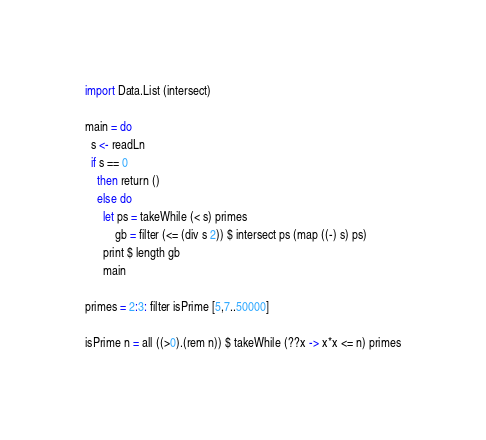Convert code to text. <code><loc_0><loc_0><loc_500><loc_500><_Haskell_>import Data.List (intersect)

main = do
  s <- readLn
  if s == 0
    then return ()
    else do
      let ps = takeWhile (< s) primes
          gb = filter (<= (div s 2)) $ intersect ps (map ((-) s) ps)
      print $ length gb
      main

primes = 2:3: filter isPrime [5,7..50000]

isPrime n = all ((>0).(rem n)) $ takeWhile (??x -> x*x <= n) primes</code> 